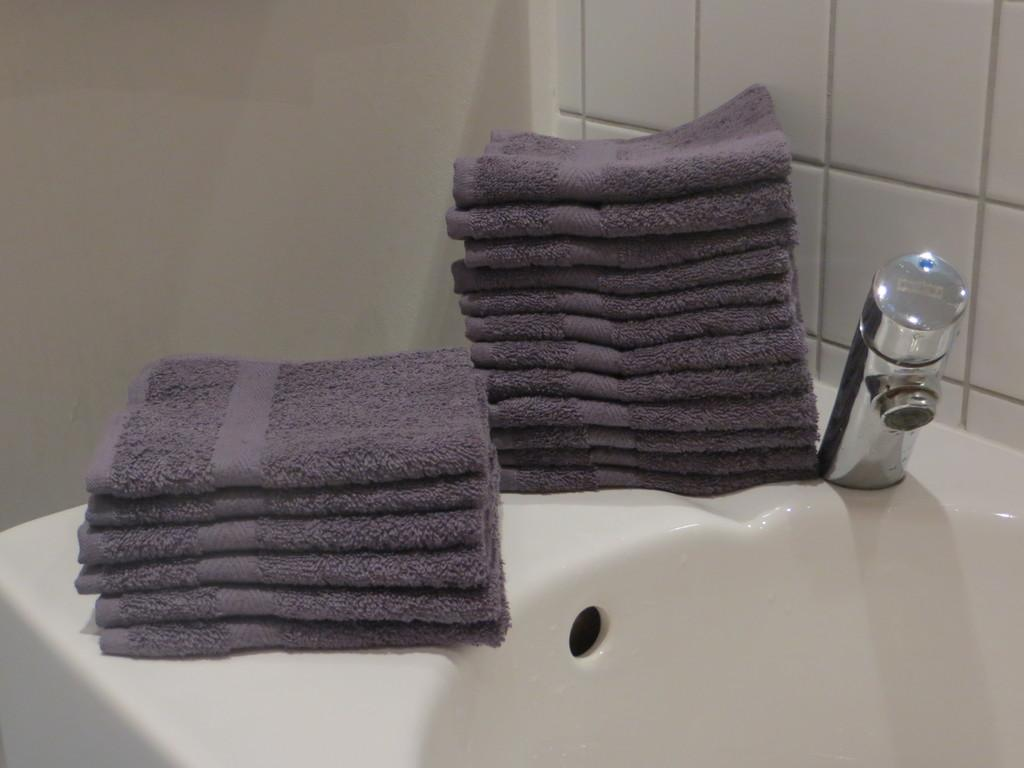What can be found in the picture? There is a wash basin, a tap, and napkins in the picture. What is the purpose of the tap in the picture? The tap is used for controlling the flow of water in the wash basin. What can be seen in the background of the picture? There is a wall in the background of the picture. What type of hearing aid is visible in the picture? There is no hearing aid present in the picture; it features a wash basin, a tap, and napkins. What type of smell can be detected in the picture? The picture does not convey any smells, as it is a visual medium. 